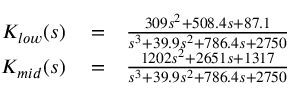<formula> <loc_0><loc_0><loc_500><loc_500>\begin{array} { r l r } { K _ { l o w } ( s ) } & = } & { \frac { 3 0 9 s ^ { 2 } + 5 0 8 . 4 s + 8 7 . 1 } { s ^ { 3 } + 3 9 . 9 s ^ { 2 } + 7 8 6 . 4 s + 2 7 5 0 } } \\ { K _ { m i d } ( s ) } & = } & { \frac { 1 2 0 2 s ^ { 2 } + 2 6 5 1 s + 1 3 1 7 } { s ^ { 3 } + 3 9 . 9 s ^ { 2 } + 7 8 6 . 4 s + 2 7 5 0 } } \end{array}</formula> 